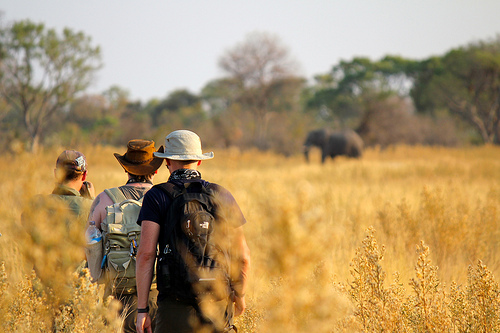That elephant is where? The elephant is on the plain. 